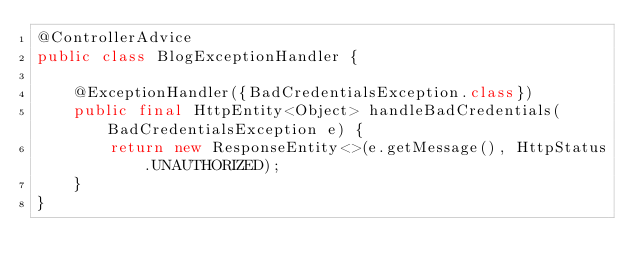<code> <loc_0><loc_0><loc_500><loc_500><_Java_>@ControllerAdvice
public class BlogExceptionHandler {

    @ExceptionHandler({BadCredentialsException.class})
    public final HttpEntity<Object> handleBadCredentials(BadCredentialsException e) {
        return new ResponseEntity<>(e.getMessage(), HttpStatus.UNAUTHORIZED);
    }
}
</code> 